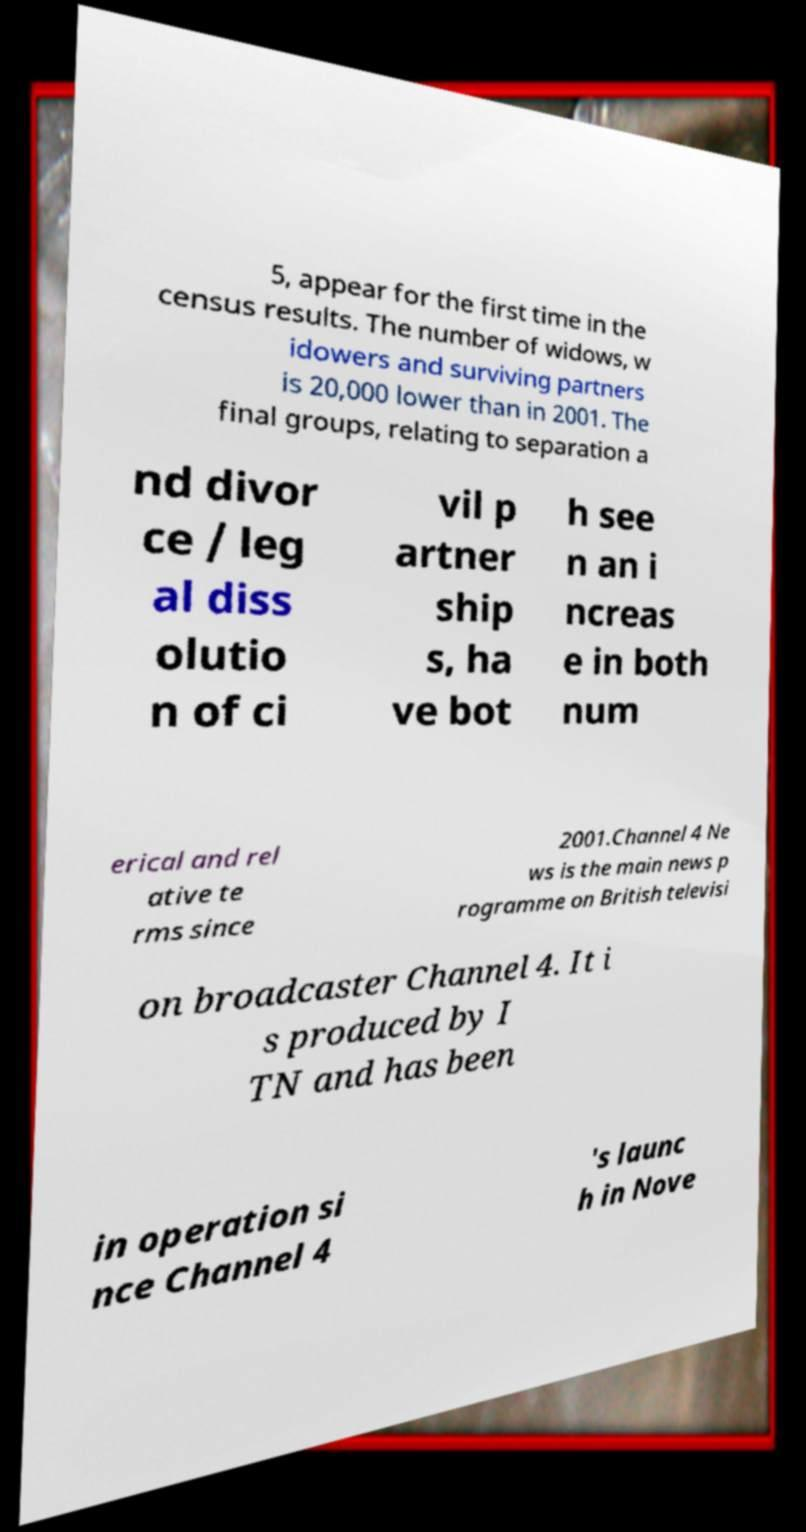What messages or text are displayed in this image? I need them in a readable, typed format. 5, appear for the first time in the census results. The number of widows, w idowers and surviving partners is 20,000 lower than in 2001. The final groups, relating to separation a nd divor ce / leg al diss olutio n of ci vil p artner ship s, ha ve bot h see n an i ncreas e in both num erical and rel ative te rms since 2001.Channel 4 Ne ws is the main news p rogramme on British televisi on broadcaster Channel 4. It i s produced by I TN and has been in operation si nce Channel 4 's launc h in Nove 